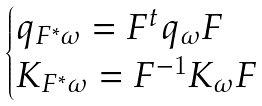<formula> <loc_0><loc_0><loc_500><loc_500>\begin{cases} q _ { F ^ { * } \omega } = F ^ { t } q _ { \omega } F & \\ K _ { F ^ { * } \omega } = F ^ { - 1 } K _ { \omega } F & \\ \end{cases}</formula> 